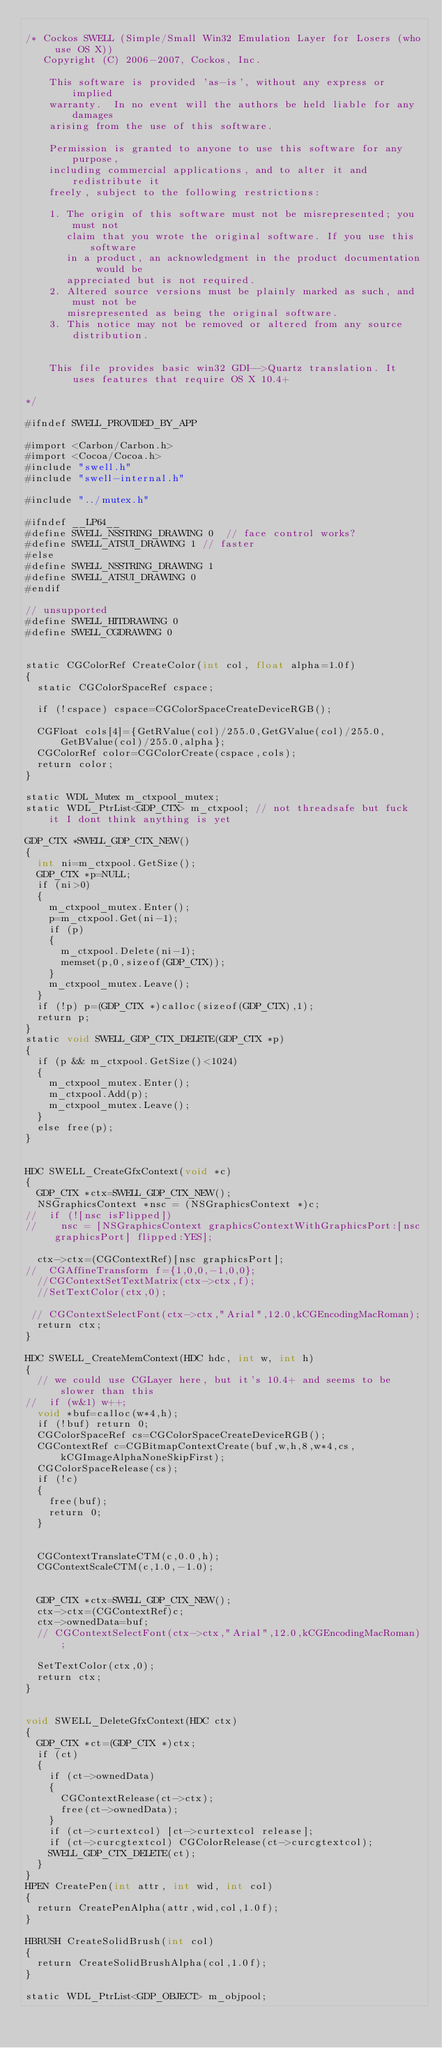<code> <loc_0><loc_0><loc_500><loc_500><_ObjectiveC_>
/* Cockos SWELL (Simple/Small Win32 Emulation Layer for Losers (who use OS X))
   Copyright (C) 2006-2007, Cockos, Inc.

    This software is provided 'as-is', without any express or implied
    warranty.  In no event will the authors be held liable for any damages
    arising from the use of this software.

    Permission is granted to anyone to use this software for any purpose,
    including commercial applications, and to alter it and redistribute it
    freely, subject to the following restrictions:

    1. The origin of this software must not be misrepresented; you must not
       claim that you wrote the original software. If you use this software
       in a product, an acknowledgment in the product documentation would be
       appreciated but is not required.
    2. Altered source versions must be plainly marked as such, and must not be
       misrepresented as being the original software.
    3. This notice may not be removed or altered from any source distribution.
  

    This file provides basic win32 GDI-->Quartz translation. It uses features that require OS X 10.4+

*/

#ifndef SWELL_PROVIDED_BY_APP

#import <Carbon/Carbon.h>
#import <Cocoa/Cocoa.h>
#include "swell.h"
#include "swell-internal.h"

#include "../mutex.h"

#ifndef __LP64__ 
#define SWELL_NSSTRING_DRAWING 0  // face control works?
#define SWELL_ATSUI_DRAWING 1 // faster
#else
#define SWELL_NSSTRING_DRAWING 1
#define SWELL_ATSUI_DRAWING 0
#endif

// unsupported
#define SWELL_HITDRAWING 0
#define SWELL_CGDRAWING 0


static CGColorRef CreateColor(int col, float alpha=1.0f)
{
  static CGColorSpaceRef cspace;
  
  if (!cspace) cspace=CGColorSpaceCreateDeviceRGB();
  
  CGFloat cols[4]={GetRValue(col)/255.0,GetGValue(col)/255.0,GetBValue(col)/255.0,alpha};
  CGColorRef color=CGColorCreate(cspace,cols);
  return color;
}

static WDL_Mutex m_ctxpool_mutex;
static WDL_PtrList<GDP_CTX> m_ctxpool; // not threadsafe but fuck it I dont think anything is yet

GDP_CTX *SWELL_GDP_CTX_NEW()
{
  int ni=m_ctxpool.GetSize();
  GDP_CTX *p=NULL;
  if (ni>0)
  {
    m_ctxpool_mutex.Enter();
    p=m_ctxpool.Get(ni-1);
    if (p)
    { 
      m_ctxpool.Delete(ni-1);
      memset(p,0,sizeof(GDP_CTX));
    }
    m_ctxpool_mutex.Leave();
  }
  if (!p) p=(GDP_CTX *)calloc(sizeof(GDP_CTX),1);
  return p;
}
static void SWELL_GDP_CTX_DELETE(GDP_CTX *p)
{
  if (p && m_ctxpool.GetSize()<1024) 
  {
    m_ctxpool_mutex.Enter();
    m_ctxpool.Add(p);
    m_ctxpool_mutex.Leave();
  }
  else free(p);
}


HDC SWELL_CreateGfxContext(void *c)
{
  GDP_CTX *ctx=SWELL_GDP_CTX_NEW();
  NSGraphicsContext *nsc = (NSGraphicsContext *)c;
//  if (![nsc isFlipped])
//    nsc = [NSGraphicsContext graphicsContextWithGraphicsPort:[nsc graphicsPort] flipped:YES];

  ctx->ctx=(CGContextRef)[nsc graphicsPort];
//  CGAffineTransform f={1,0,0,-1,0,0};
  //CGContextSetTextMatrix(ctx->ctx,f);
  //SetTextColor(ctx,0);
  
 // CGContextSelectFont(ctx->ctx,"Arial",12.0,kCGEncodingMacRoman);
  return ctx;
}

HDC SWELL_CreateMemContext(HDC hdc, int w, int h)
{
  // we could use CGLayer here, but it's 10.4+ and seems to be slower than this
//  if (w&1) w++;
  void *buf=calloc(w*4,h);
  if (!buf) return 0;
  CGColorSpaceRef cs=CGColorSpaceCreateDeviceRGB();
  CGContextRef c=CGBitmapContextCreate(buf,w,h,8,w*4,cs, kCGImageAlphaNoneSkipFirst);
  CGColorSpaceRelease(cs);
  if (!c)
  {
    free(buf);
    return 0;
  }


  CGContextTranslateCTM(c,0.0,h);
  CGContextScaleCTM(c,1.0,-1.0);


  GDP_CTX *ctx=SWELL_GDP_CTX_NEW();
  ctx->ctx=(CGContextRef)c;
  ctx->ownedData=buf;
  // CGContextSelectFont(ctx->ctx,"Arial",12.0,kCGEncodingMacRoman);
  
  SetTextColor(ctx,0);
  return ctx;
}


void SWELL_DeleteGfxContext(HDC ctx)
{
  GDP_CTX *ct=(GDP_CTX *)ctx;
  if (ct)
  {   
    if (ct->ownedData)
    {
      CGContextRelease(ct->ctx);
      free(ct->ownedData);
    }
    if (ct->curtextcol) [ct->curtextcol release];
    if (ct->curcgtextcol) CGColorRelease(ct->curcgtextcol);
    SWELL_GDP_CTX_DELETE(ct);
  }
}
HPEN CreatePen(int attr, int wid, int col)
{
  return CreatePenAlpha(attr,wid,col,1.0f);
}

HBRUSH CreateSolidBrush(int col)
{
  return CreateSolidBrushAlpha(col,1.0f);
}

static WDL_PtrList<GDP_OBJECT> m_objpool;</code> 